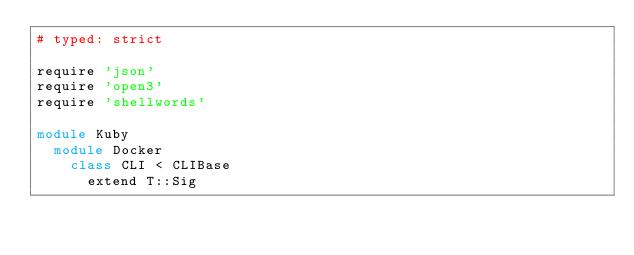Convert code to text. <code><loc_0><loc_0><loc_500><loc_500><_Ruby_># typed: strict

require 'json'
require 'open3'
require 'shellwords'

module Kuby
  module Docker
    class CLI < CLIBase
      extend T::Sig
</code> 